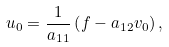<formula> <loc_0><loc_0><loc_500><loc_500>u _ { 0 } = \frac { 1 } { a _ { 1 1 } } \left ( f - a _ { 1 2 } v _ { 0 } \right ) ,</formula> 